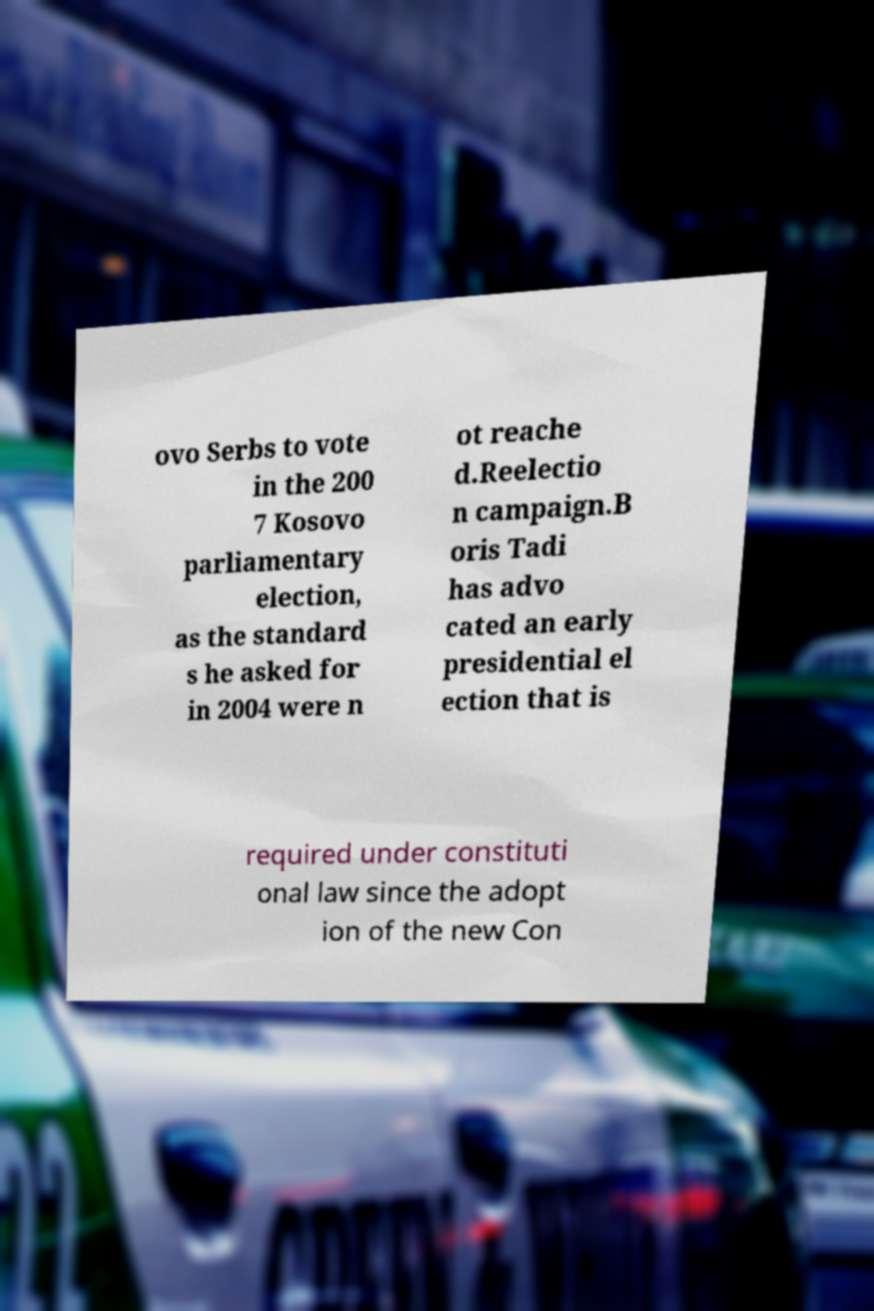Can you accurately transcribe the text from the provided image for me? ovo Serbs to vote in the 200 7 Kosovo parliamentary election, as the standard s he asked for in 2004 were n ot reache d.Reelectio n campaign.B oris Tadi has advo cated an early presidential el ection that is required under constituti onal law since the adopt ion of the new Con 